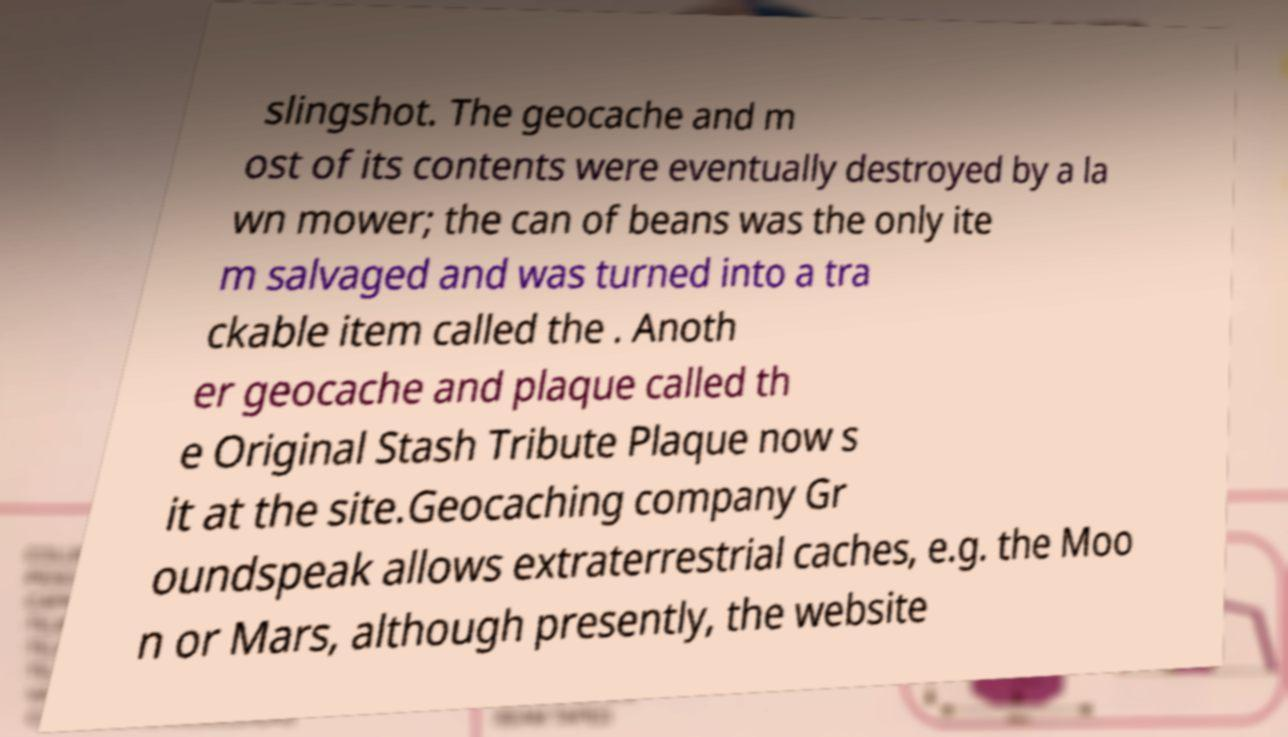Please read and relay the text visible in this image. What does it say? slingshot. The geocache and m ost of its contents were eventually destroyed by a la wn mower; the can of beans was the only ite m salvaged and was turned into a tra ckable item called the . Anoth er geocache and plaque called th e Original Stash Tribute Plaque now s it at the site.Geocaching company Gr oundspeak allows extraterrestrial caches, e.g. the Moo n or Mars, although presently, the website 